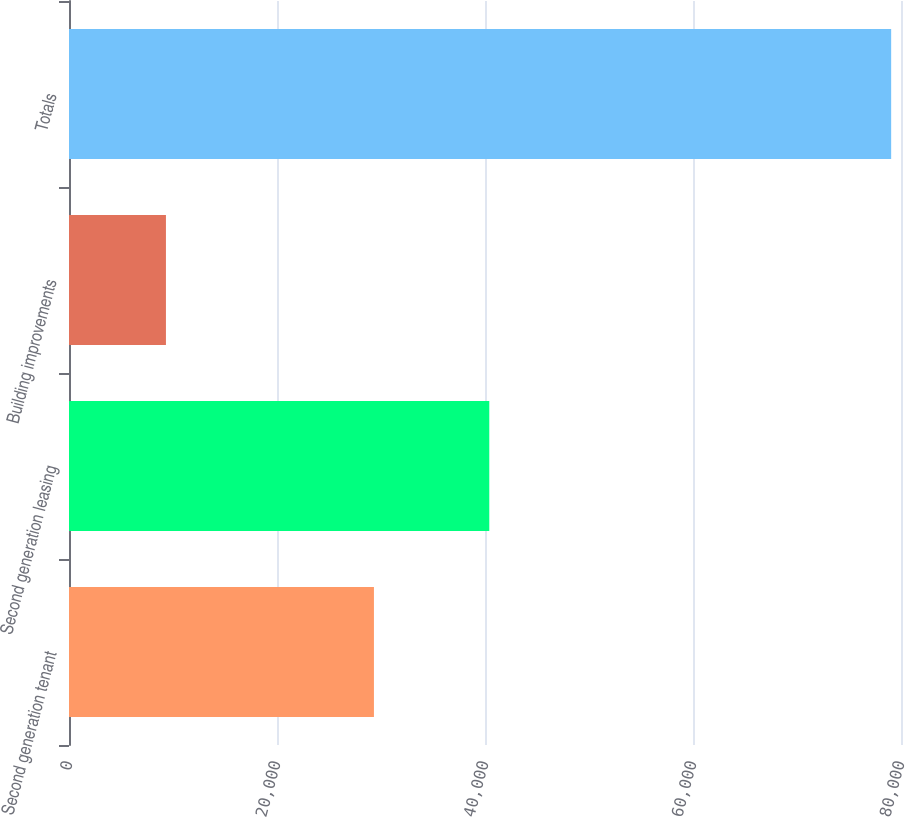<chart> <loc_0><loc_0><loc_500><loc_500><bar_chart><fcel>Second generation tenant<fcel>Second generation leasing<fcel>Building improvements<fcel>Totals<nl><fcel>29321<fcel>40412<fcel>9321<fcel>79054<nl></chart> 